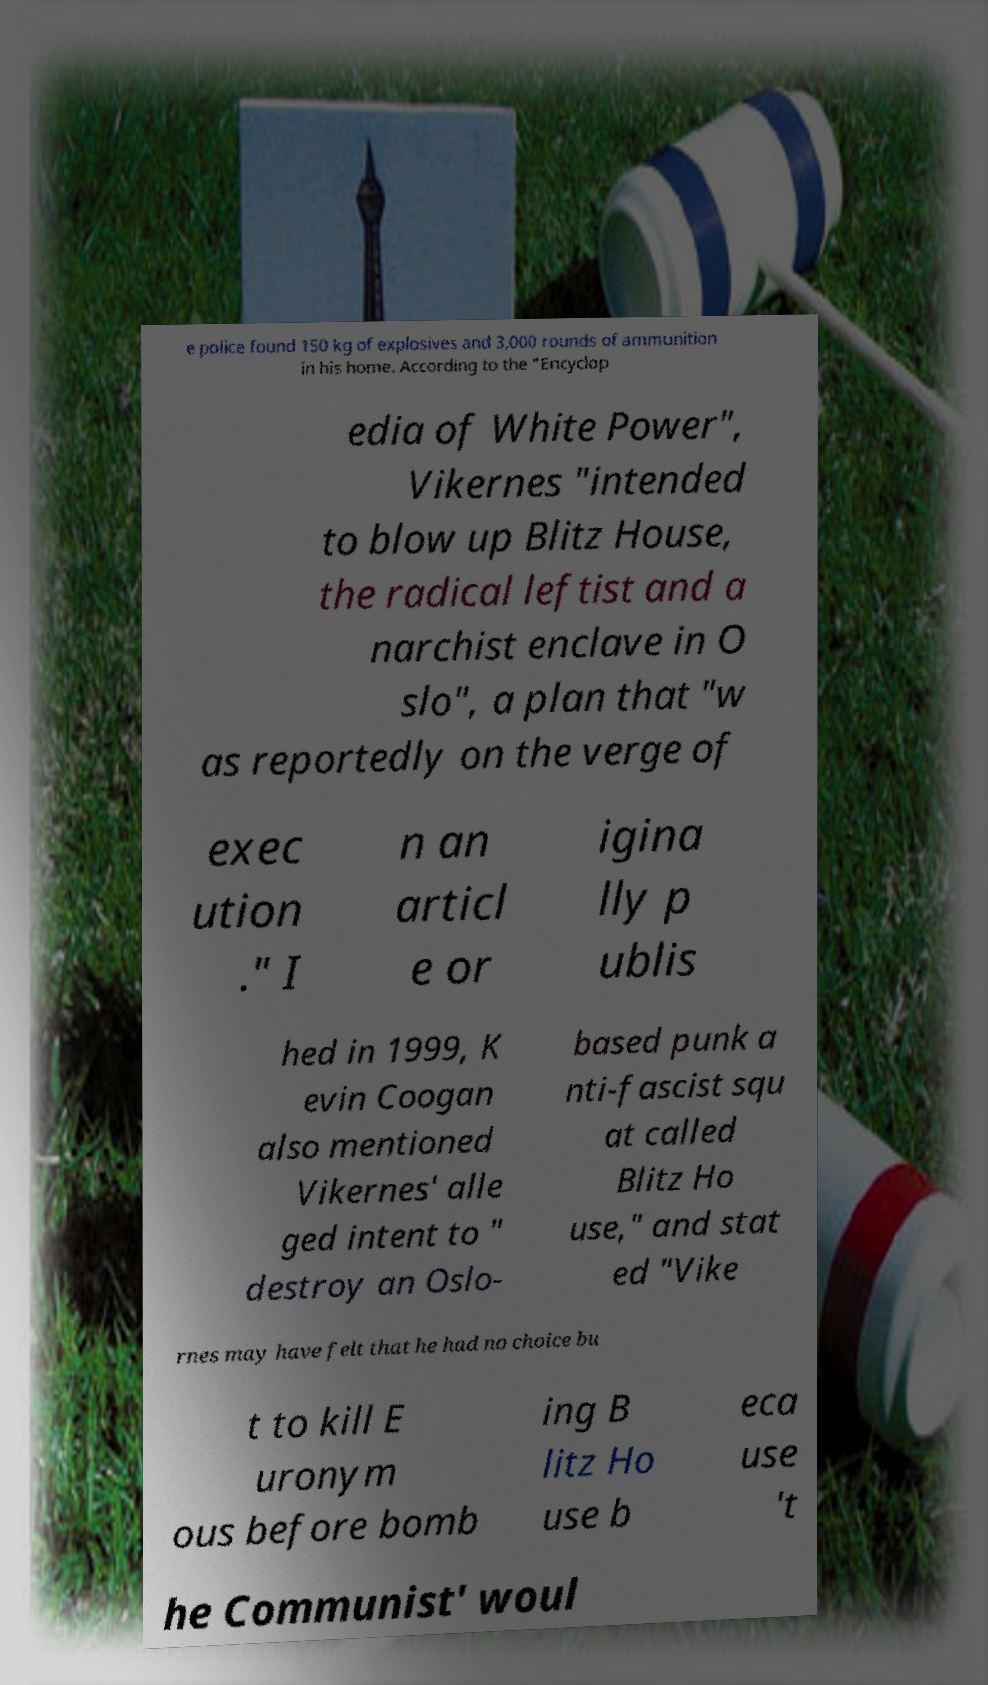There's text embedded in this image that I need extracted. Can you transcribe it verbatim? e police found 150 kg of explosives and 3,000 rounds of ammunition in his home. According to the "Encyclop edia of White Power", Vikernes "intended to blow up Blitz House, the radical leftist and a narchist enclave in O slo", a plan that "w as reportedly on the verge of exec ution ." I n an articl e or igina lly p ublis hed in 1999, K evin Coogan also mentioned Vikernes' alle ged intent to " destroy an Oslo- based punk a nti-fascist squ at called Blitz Ho use," and stat ed "Vike rnes may have felt that he had no choice bu t to kill E uronym ous before bomb ing B litz Ho use b eca use 't he Communist' woul 